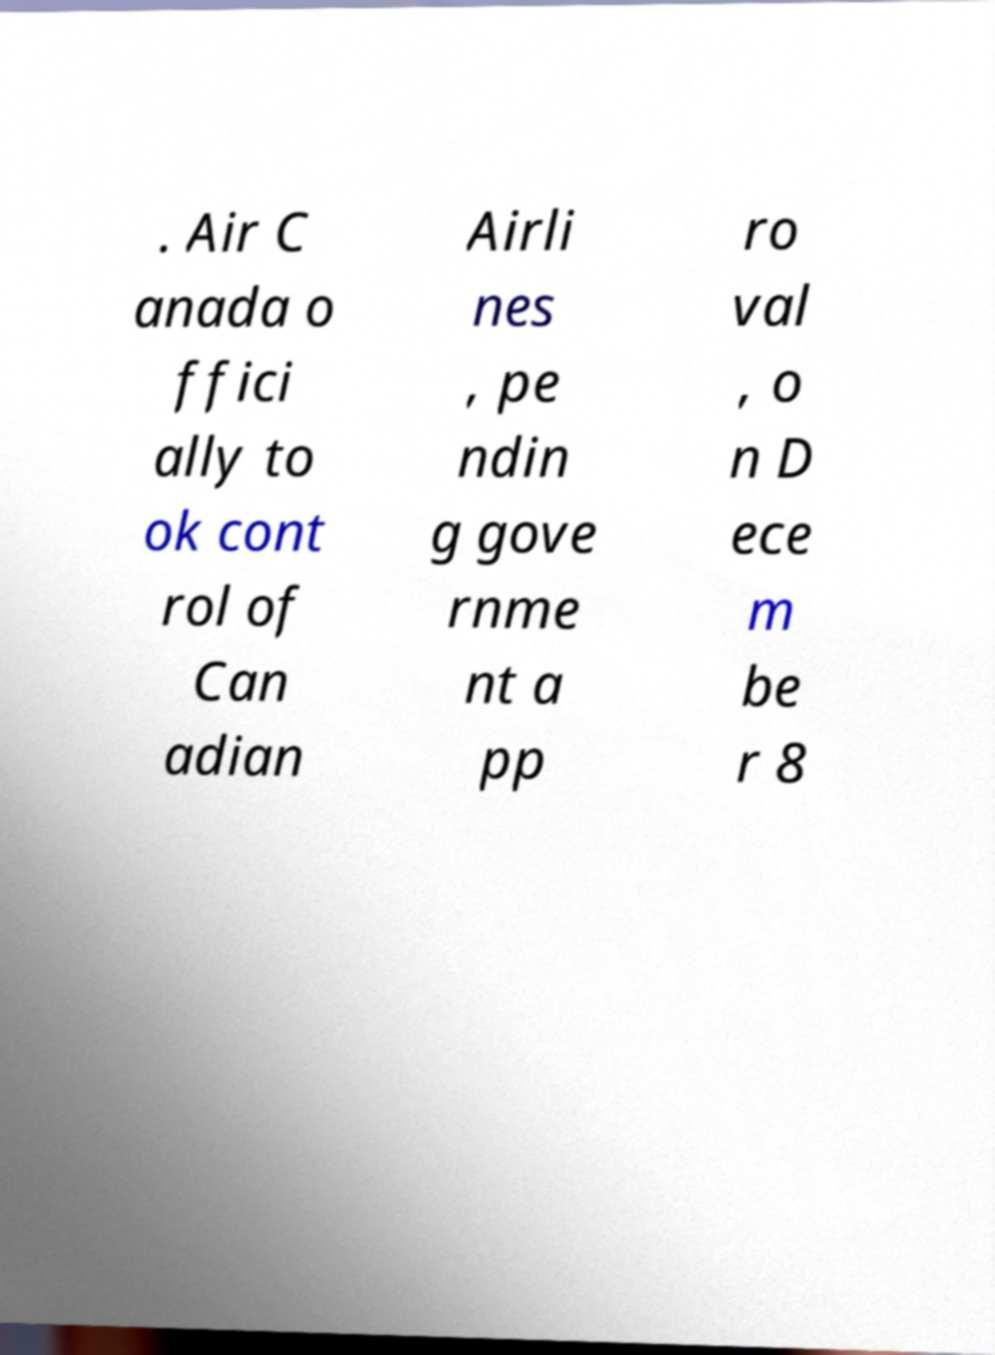For documentation purposes, I need the text within this image transcribed. Could you provide that? . Air C anada o ffici ally to ok cont rol of Can adian Airli nes , pe ndin g gove rnme nt a pp ro val , o n D ece m be r 8 